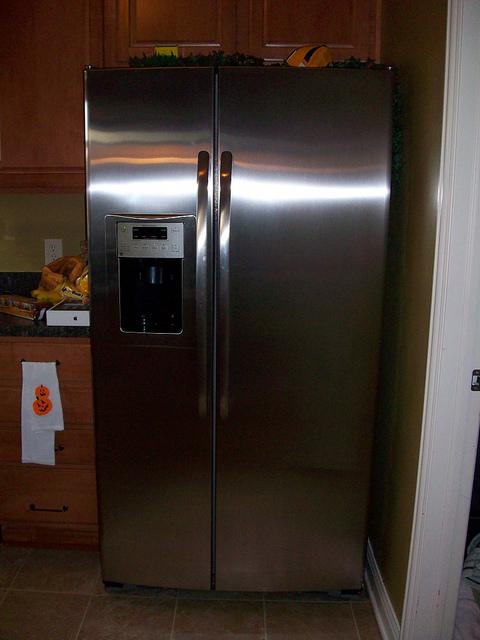What is to the left of the fridge?
Write a very short answer. Counter. What is the color of the fridge?
Be succinct. Silver. What is the sticker located on the towel?
Write a very short answer. Pumpkin. Does the refrigerator shine?
Give a very brief answer. Yes. Is this a normal location for a refrigerator?
Quick response, please. Yes. 